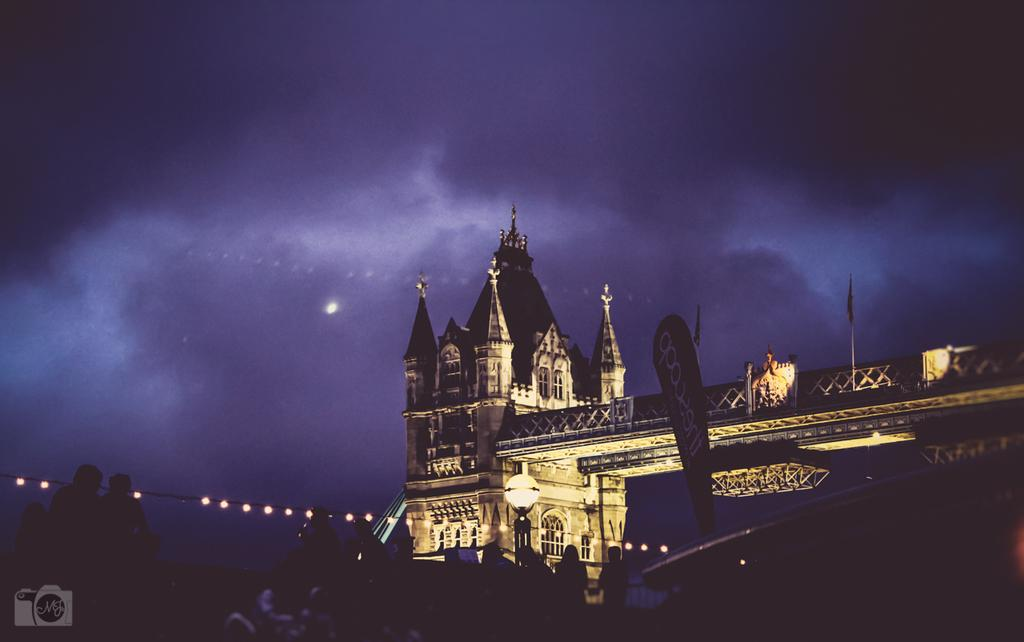What can be seen in the foreground of the image? There are people, a building, lights, and a banner flag-like object in the foreground of the image. Can you describe the people in the image? The facts provided do not give specific details about the people, so we cannot describe them. What is the condition of the sky in the image? The sky is dark at the top of the image. What type of yam is being used to cover the building in the image? There is no yam present in the image, and the building is not being covered by any object. Can you describe the stranger in the image? The facts provided do not mention a stranger, so we cannot describe one. 